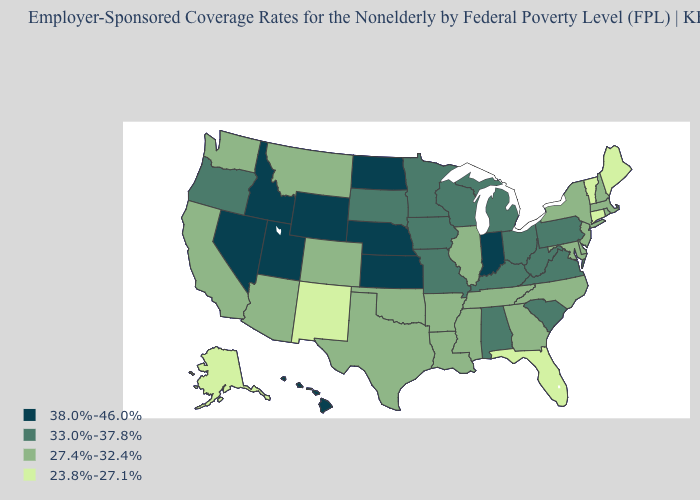What is the lowest value in states that border Kansas?
Answer briefly. 27.4%-32.4%. Among the states that border Idaho , does Nevada have the highest value?
Short answer required. Yes. What is the value of North Carolina?
Give a very brief answer. 27.4%-32.4%. What is the value of Iowa?
Quick response, please. 33.0%-37.8%. Which states have the lowest value in the Northeast?
Answer briefly. Connecticut, Maine, Vermont. Is the legend a continuous bar?
Write a very short answer. No. Does Idaho have the same value as Indiana?
Quick response, please. Yes. What is the highest value in the South ?
Keep it brief. 33.0%-37.8%. What is the value of Maine?
Write a very short answer. 23.8%-27.1%. Does the first symbol in the legend represent the smallest category?
Be succinct. No. What is the value of Hawaii?
Give a very brief answer. 38.0%-46.0%. What is the value of New York?
Write a very short answer. 27.4%-32.4%. What is the value of Maine?
Be succinct. 23.8%-27.1%. Does Nevada have the same value as Kansas?
Quick response, please. Yes. 